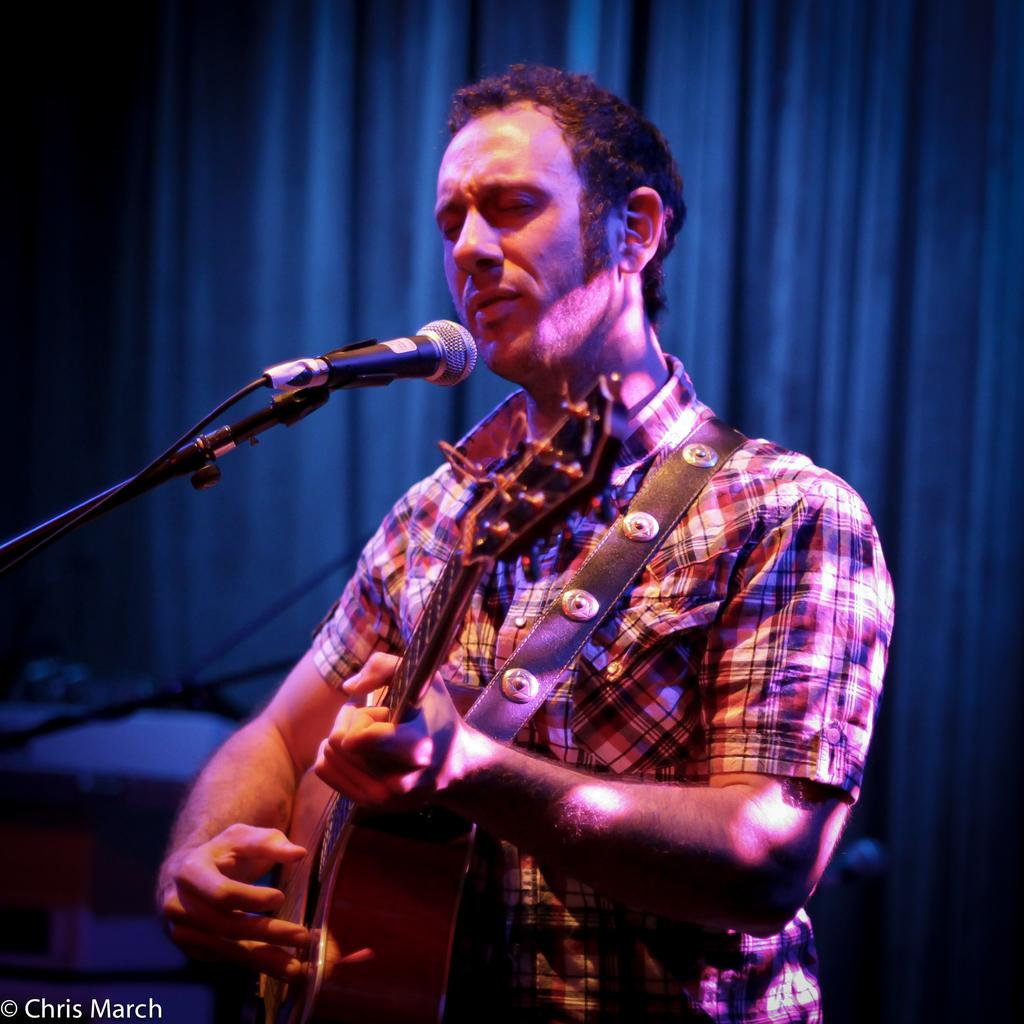What is the man in the image doing? The man is playing the guitar. What object is the man holding in the image? The man is holding a guitar. What is in front of the man in the image? There is a microphone in front of the man. What can be seen behind the man in the image? There is a curtain behind the man. How does the man express disgust in the image? The image does not show the man expressing disgust; he is playing the guitar and there is no indication of any negative emotions. 